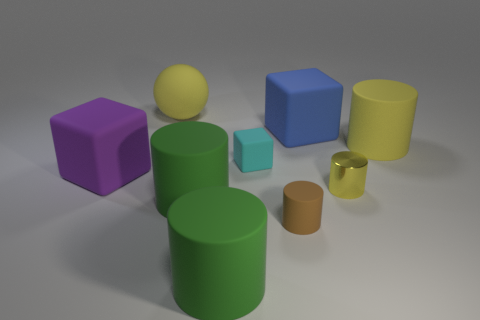What is the size of the matte cylinder that is the same color as the large ball?
Ensure brevity in your answer.  Large. There is a metal object that is the same color as the ball; what shape is it?
Your response must be concise. Cylinder. There is a big cylinder that is behind the rubber object to the left of the sphere; what number of small yellow cylinders are behind it?
Your answer should be very brief. 0. What is the shape of the large blue rubber thing?
Your answer should be very brief. Cube. What number of other things are there of the same material as the tiny cyan object
Your answer should be compact. 7. Is the size of the brown thing the same as the blue rubber cube?
Ensure brevity in your answer.  No. There is a rubber thing that is to the right of the big blue matte thing; what is its shape?
Make the answer very short. Cylinder. The cube behind the cylinder that is behind the large purple cube is what color?
Your response must be concise. Blue. There is a large thing that is behind the blue thing; does it have the same shape as the small object behind the small metal cylinder?
Provide a short and direct response. No. There is a blue rubber object that is the same size as the purple block; what is its shape?
Your response must be concise. Cube. 